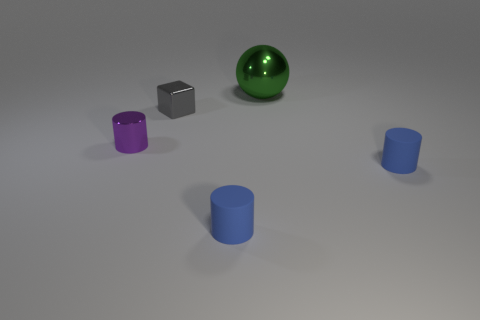Add 3 purple objects. How many objects exist? 8 Subtract all purple cylinders. How many cylinders are left? 2 Subtract all small purple cylinders. How many cylinders are left? 2 Subtract all cylinders. How many objects are left? 2 Subtract 1 cubes. How many cubes are left? 0 Subtract all purple cylinders. Subtract all red balls. How many cylinders are left? 2 Subtract all gray balls. How many cyan cylinders are left? 0 Subtract all small cylinders. Subtract all green objects. How many objects are left? 1 Add 1 small blue matte things. How many small blue matte things are left? 3 Add 5 gray blocks. How many gray blocks exist? 6 